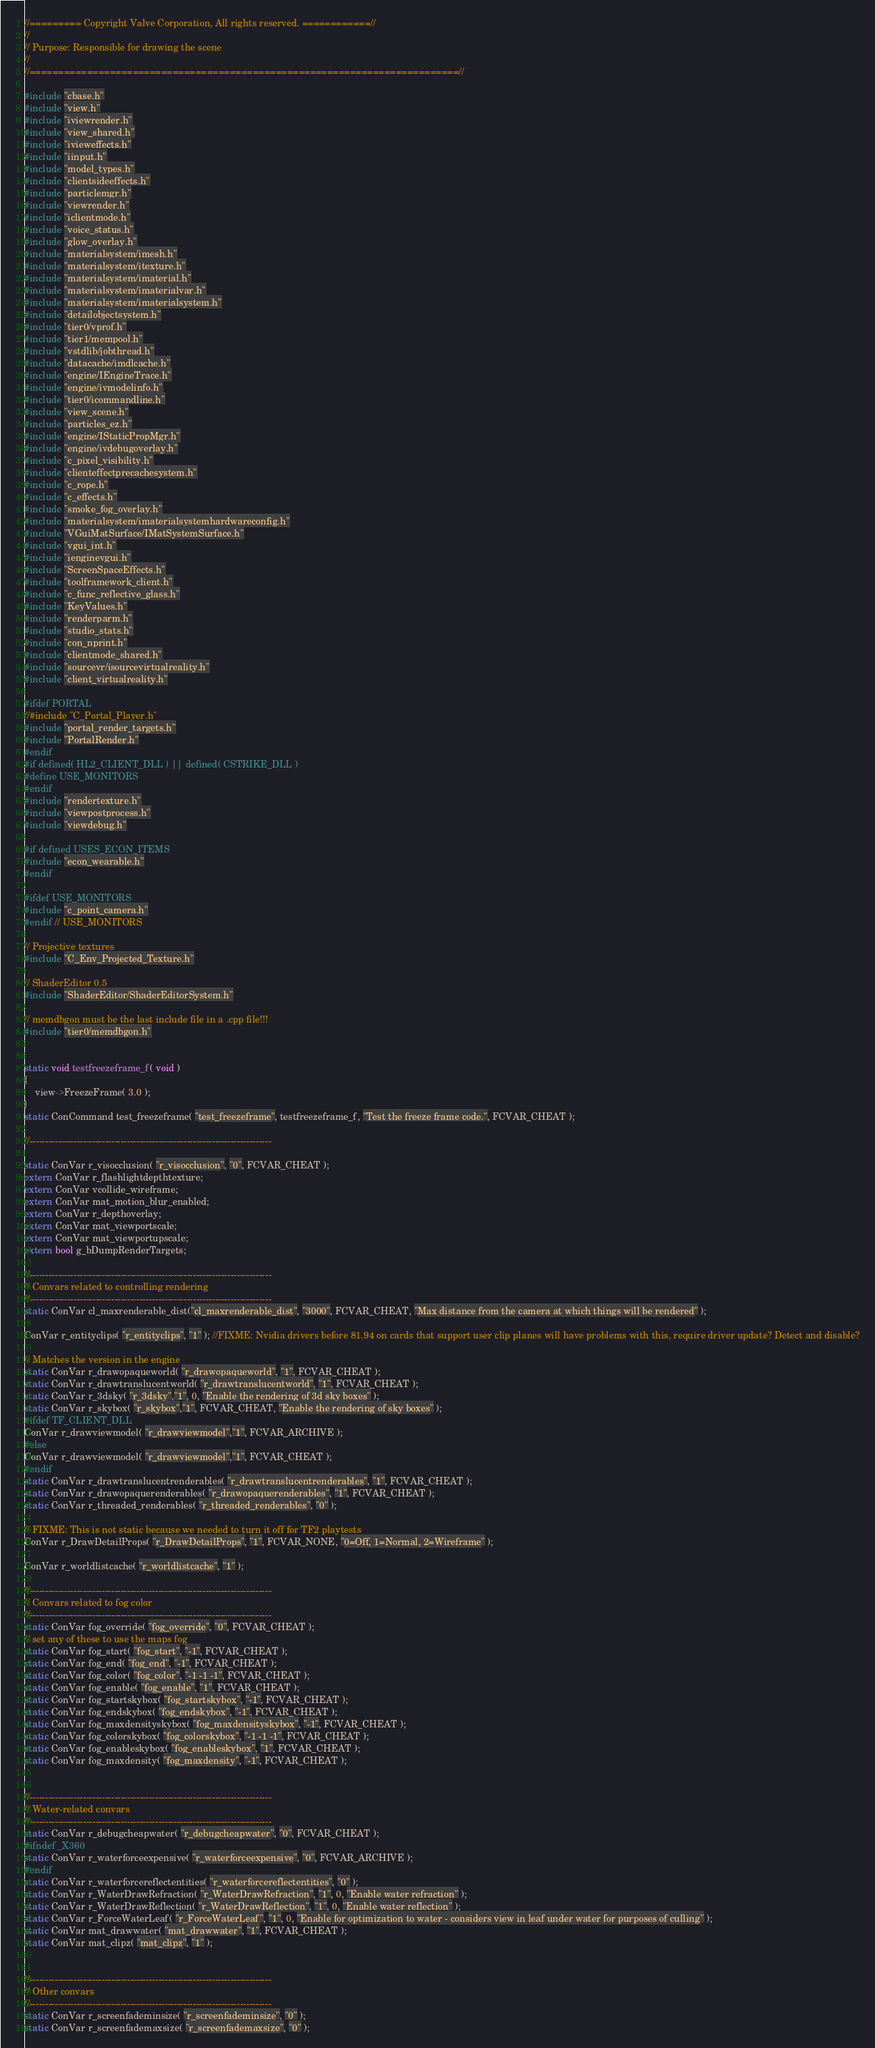Convert code to text. <code><loc_0><loc_0><loc_500><loc_500><_C++_>//========= Copyright Valve Corporation, All rights reserved. ============//
//
// Purpose: Responsible for drawing the scene
//
//===========================================================================//

#include "cbase.h"
#include "view.h"
#include "iviewrender.h"
#include "view_shared.h"
#include "ivieweffects.h"
#include "iinput.h"
#include "model_types.h"
#include "clientsideeffects.h"
#include "particlemgr.h"
#include "viewrender.h"
#include "iclientmode.h"
#include "voice_status.h"
#include "glow_overlay.h"
#include "materialsystem/imesh.h"
#include "materialsystem/itexture.h"
#include "materialsystem/imaterial.h"
#include "materialsystem/imaterialvar.h"
#include "materialsystem/imaterialsystem.h"
#include "detailobjectsystem.h"
#include "tier0/vprof.h"
#include "tier1/mempool.h"
#include "vstdlib/jobthread.h"
#include "datacache/imdlcache.h"
#include "engine/IEngineTrace.h"
#include "engine/ivmodelinfo.h"
#include "tier0/icommandline.h"
#include "view_scene.h"
#include "particles_ez.h"
#include "engine/IStaticPropMgr.h"
#include "engine/ivdebugoverlay.h"
#include "c_pixel_visibility.h"
#include "clienteffectprecachesystem.h"
#include "c_rope.h"
#include "c_effects.h"
#include "smoke_fog_overlay.h"
#include "materialsystem/imaterialsystemhardwareconfig.h"
#include "VGuiMatSurface/IMatSystemSurface.h"
#include "vgui_int.h"
#include "ienginevgui.h"
#include "ScreenSpaceEffects.h"
#include "toolframework_client.h"
#include "c_func_reflective_glass.h"
#include "KeyValues.h"
#include "renderparm.h"
#include "studio_stats.h"
#include "con_nprint.h"
#include "clientmode_shared.h"
#include "sourcevr/isourcevirtualreality.h"
#include "client_virtualreality.h"

#ifdef PORTAL
//#include "C_Portal_Player.h"
#include "portal_render_targets.h"
#include "PortalRender.h"
#endif
#if defined( HL2_CLIENT_DLL ) || defined( CSTRIKE_DLL )
#define USE_MONITORS
#endif
#include "rendertexture.h"
#include "viewpostprocess.h"
#include "viewdebug.h"

#if defined USES_ECON_ITEMS
#include "econ_wearable.h"
#endif

#ifdef USE_MONITORS
#include "c_point_camera.h"
#endif // USE_MONITORS

// Projective textures
#include "C_Env_Projected_Texture.h"

// ShaderEditor 0.5
#include "ShaderEditor/ShaderEditorSystem.h"

// memdbgon must be the last include file in a .cpp file!!!
#include "tier0/memdbgon.h"


static void testfreezeframe_f( void )
{
	view->FreezeFrame( 3.0 );
}
static ConCommand test_freezeframe( "test_freezeframe", testfreezeframe_f, "Test the freeze frame code.", FCVAR_CHEAT );

//-----------------------------------------------------------------------------

static ConVar r_visocclusion( "r_visocclusion", "0", FCVAR_CHEAT );
extern ConVar r_flashlightdepthtexture;
extern ConVar vcollide_wireframe;
extern ConVar mat_motion_blur_enabled;
extern ConVar r_depthoverlay;
extern ConVar mat_viewportscale;
extern ConVar mat_viewportupscale;
extern bool g_bDumpRenderTargets;

//-----------------------------------------------------------------------------
// Convars related to controlling rendering
//-----------------------------------------------------------------------------
static ConVar cl_maxrenderable_dist("cl_maxrenderable_dist", "3000", FCVAR_CHEAT, "Max distance from the camera at which things will be rendered" );

ConVar r_entityclips( "r_entityclips", "1" ); //FIXME: Nvidia drivers before 81.94 on cards that support user clip planes will have problems with this, require driver update? Detect and disable?

// Matches the version in the engine
static ConVar r_drawopaqueworld( "r_drawopaqueworld", "1", FCVAR_CHEAT );
static ConVar r_drawtranslucentworld( "r_drawtranslucentworld", "1", FCVAR_CHEAT );
static ConVar r_3dsky( "r_3dsky","1", 0, "Enable the rendering of 3d sky boxes" );
static ConVar r_skybox( "r_skybox","1", FCVAR_CHEAT, "Enable the rendering of sky boxes" );
#ifdef TF_CLIENT_DLL
ConVar r_drawviewmodel( "r_drawviewmodel","1", FCVAR_ARCHIVE );
#else
ConVar r_drawviewmodel( "r_drawviewmodel","1", FCVAR_CHEAT );
#endif
static ConVar r_drawtranslucentrenderables( "r_drawtranslucentrenderables", "1", FCVAR_CHEAT );
static ConVar r_drawopaquerenderables( "r_drawopaquerenderables", "1", FCVAR_CHEAT );
static ConVar r_threaded_renderables( "r_threaded_renderables", "0" );

// FIXME: This is not static because we needed to turn it off for TF2 playtests
ConVar r_DrawDetailProps( "r_DrawDetailProps", "1", FCVAR_NONE, "0=Off, 1=Normal, 2=Wireframe" );

ConVar r_worldlistcache( "r_worldlistcache", "1" );

//-----------------------------------------------------------------------------
// Convars related to fog color
//-----------------------------------------------------------------------------
static ConVar fog_override( "fog_override", "0", FCVAR_CHEAT );
// set any of these to use the maps fog
static ConVar fog_start( "fog_start", "-1", FCVAR_CHEAT );
static ConVar fog_end( "fog_end", "-1", FCVAR_CHEAT );
static ConVar fog_color( "fog_color", "-1 -1 -1", FCVAR_CHEAT );
static ConVar fog_enable( "fog_enable", "1", FCVAR_CHEAT );
static ConVar fog_startskybox( "fog_startskybox", "-1", FCVAR_CHEAT );
static ConVar fog_endskybox( "fog_endskybox", "-1", FCVAR_CHEAT );
static ConVar fog_maxdensityskybox( "fog_maxdensityskybox", "-1", FCVAR_CHEAT );
static ConVar fog_colorskybox( "fog_colorskybox", "-1 -1 -1", FCVAR_CHEAT );
static ConVar fog_enableskybox( "fog_enableskybox", "1", FCVAR_CHEAT );
static ConVar fog_maxdensity( "fog_maxdensity", "-1", FCVAR_CHEAT );


//-----------------------------------------------------------------------------
// Water-related convars
//-----------------------------------------------------------------------------
static ConVar r_debugcheapwater( "r_debugcheapwater", "0", FCVAR_CHEAT );
#ifndef _X360
static ConVar r_waterforceexpensive( "r_waterforceexpensive", "0", FCVAR_ARCHIVE );
#endif
static ConVar r_waterforcereflectentities( "r_waterforcereflectentities", "0" );
static ConVar r_WaterDrawRefraction( "r_WaterDrawRefraction", "1", 0, "Enable water refraction" );
static ConVar r_WaterDrawReflection( "r_WaterDrawReflection", "1", 0, "Enable water reflection" );
static ConVar r_ForceWaterLeaf( "r_ForceWaterLeaf", "1", 0, "Enable for optimization to water - considers view in leaf under water for purposes of culling" );
static ConVar mat_drawwater( "mat_drawwater", "1", FCVAR_CHEAT );
static ConVar mat_clipz( "mat_clipz", "1" );


//-----------------------------------------------------------------------------
// Other convars
//-----------------------------------------------------------------------------
static ConVar r_screenfademinsize( "r_screenfademinsize", "0" );
static ConVar r_screenfademaxsize( "r_screenfademaxsize", "0" );</code> 